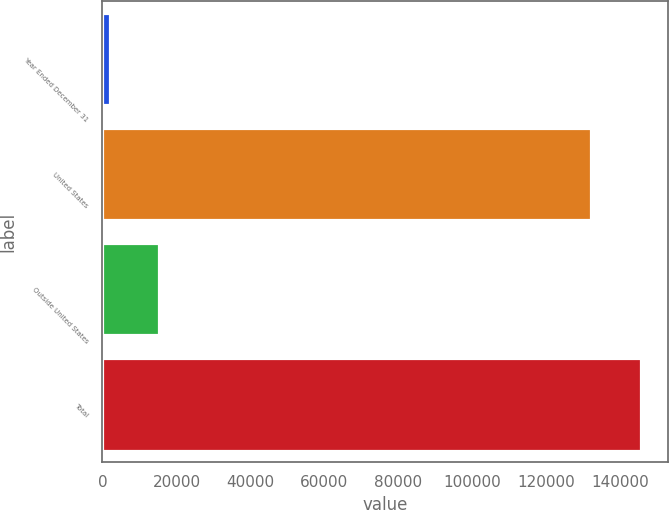Convert chart to OTSL. <chart><loc_0><loc_0><loc_500><loc_500><bar_chart><fcel>Year Ended December 31<fcel>United States<fcel>Outside United States<fcel>Total<nl><fcel>2003<fcel>132056<fcel>15401.9<fcel>145455<nl></chart> 